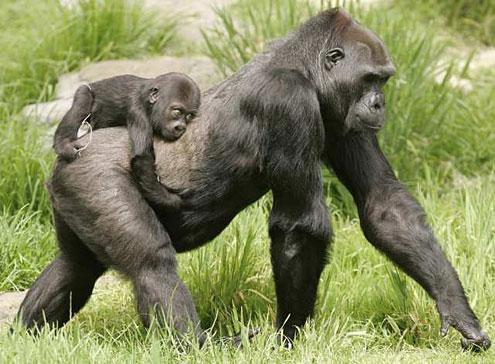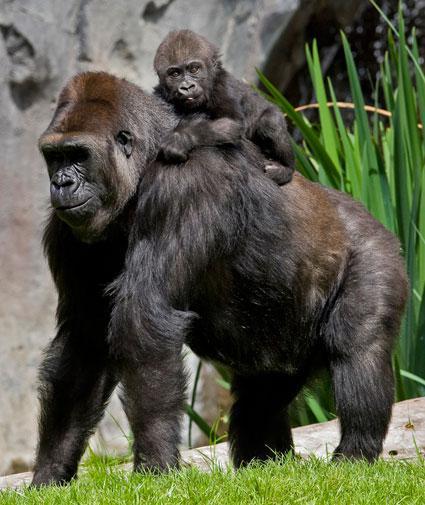The first image is the image on the left, the second image is the image on the right. For the images displayed, is the sentence "An image shows a baby gorilla clinging on the back near the shoulders of an adult gorilla." factually correct? Answer yes or no. Yes. The first image is the image on the left, the second image is the image on the right. Examine the images to the left and right. Is the description "At least one of the images shows an adult gorilla carrying a baby gorilla on their back, with the baby touching the adult's shoulders." accurate? Answer yes or no. Yes. 